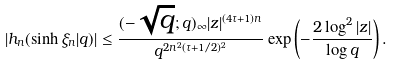<formula> <loc_0><loc_0><loc_500><loc_500>\left | h _ { n } ( \sinh \xi _ { n } | q ) \right | \leq \frac { ( - \sqrt { q } ; q ) _ { \infty } | z | ^ { ( 4 \tau + 1 ) n } } { q ^ { 2 n ^ { 2 } ( \tau + 1 / 2 ) ^ { 2 } } } \exp \left ( - \frac { 2 \log ^ { 2 } | z | } { \log q } \right ) .</formula> 